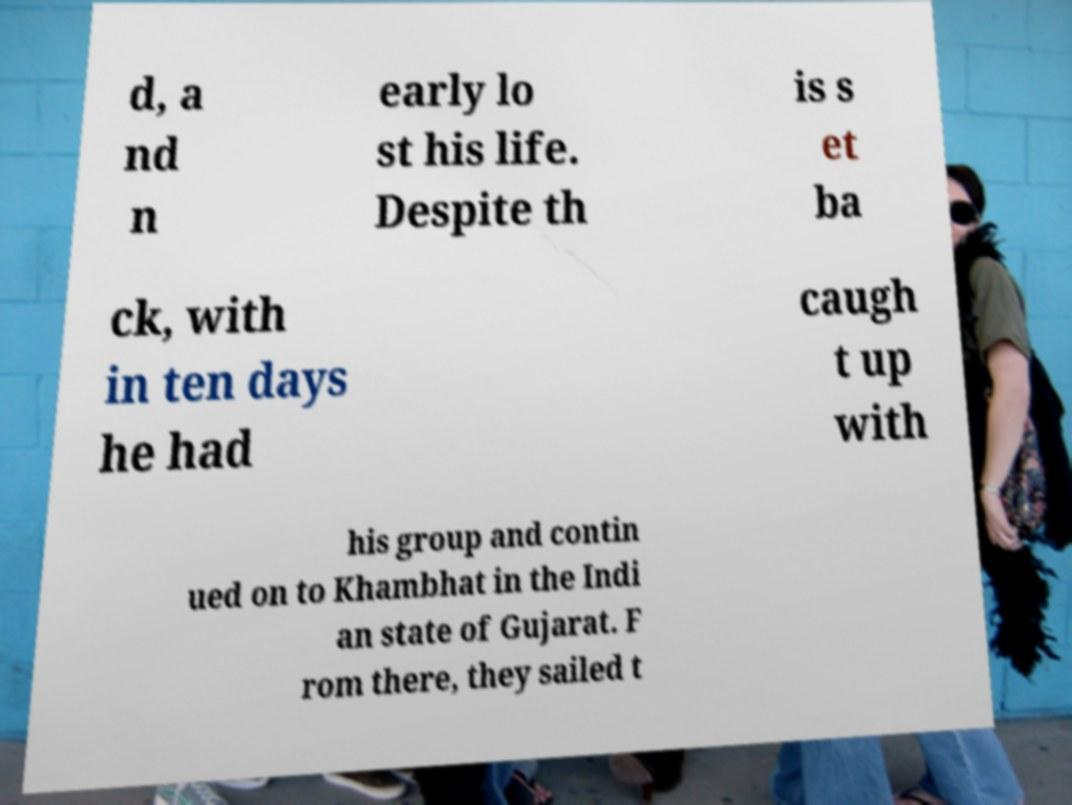Can you accurately transcribe the text from the provided image for me? d, a nd n early lo st his life. Despite th is s et ba ck, with in ten days he had caugh t up with his group and contin ued on to Khambhat in the Indi an state of Gujarat. F rom there, they sailed t 